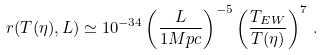Convert formula to latex. <formula><loc_0><loc_0><loc_500><loc_500>r ( T ( \eta ) , L ) \simeq 1 0 ^ { - 3 4 } \left ( \frac { L } { 1 M p c } \right ) ^ { - 5 } \left ( \frac { T _ { E W } } { T ( \eta ) } \right ) ^ { 7 } \, .</formula> 